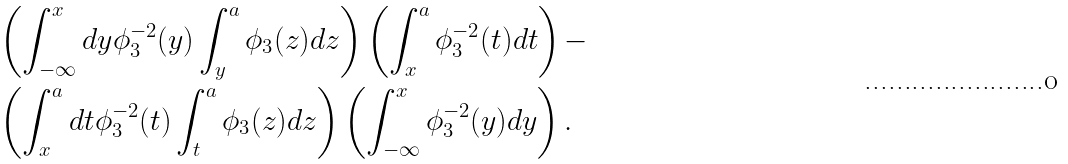Convert formula to latex. <formula><loc_0><loc_0><loc_500><loc_500>& \left ( \int _ { - \infty } ^ { x } d y \phi _ { 3 } ^ { - 2 } ( y ) \int _ { y } ^ { a } \phi _ { 3 } ( z ) d z \right ) \left ( \int _ { x } ^ { a } \phi _ { 3 } ^ { - 2 } ( t ) d t \right ) - \\ & \left ( \int _ { x } ^ { a } d t \phi _ { 3 } ^ { - 2 } ( t ) \int _ { t } ^ { a } \phi _ { 3 } ( z ) d z \right ) \left ( \int _ { - \infty } ^ { x } \phi _ { 3 } ^ { - 2 } ( y ) d y \right ) .</formula> 